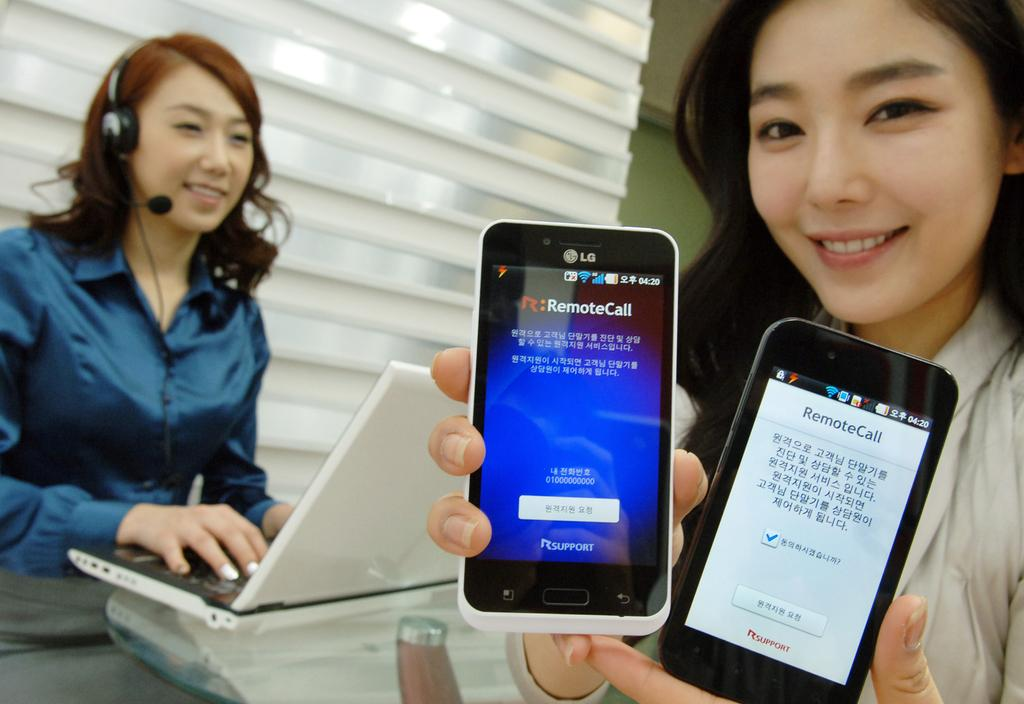<image>
Summarize the visual content of the image. A woman is holding two cell phones which display RemoteCall on the screen. 